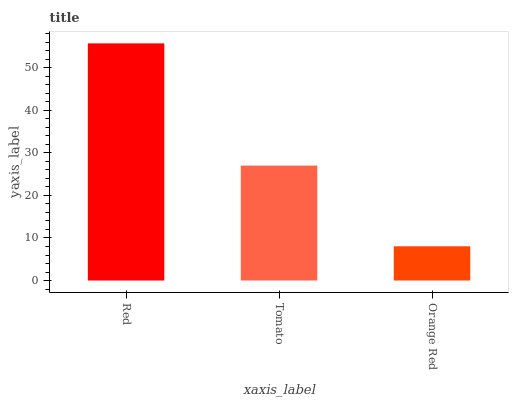Is Orange Red the minimum?
Answer yes or no. Yes. Is Red the maximum?
Answer yes or no. Yes. Is Tomato the minimum?
Answer yes or no. No. Is Tomato the maximum?
Answer yes or no. No. Is Red greater than Tomato?
Answer yes or no. Yes. Is Tomato less than Red?
Answer yes or no. Yes. Is Tomato greater than Red?
Answer yes or no. No. Is Red less than Tomato?
Answer yes or no. No. Is Tomato the high median?
Answer yes or no. Yes. Is Tomato the low median?
Answer yes or no. Yes. Is Red the high median?
Answer yes or no. No. Is Red the low median?
Answer yes or no. No. 